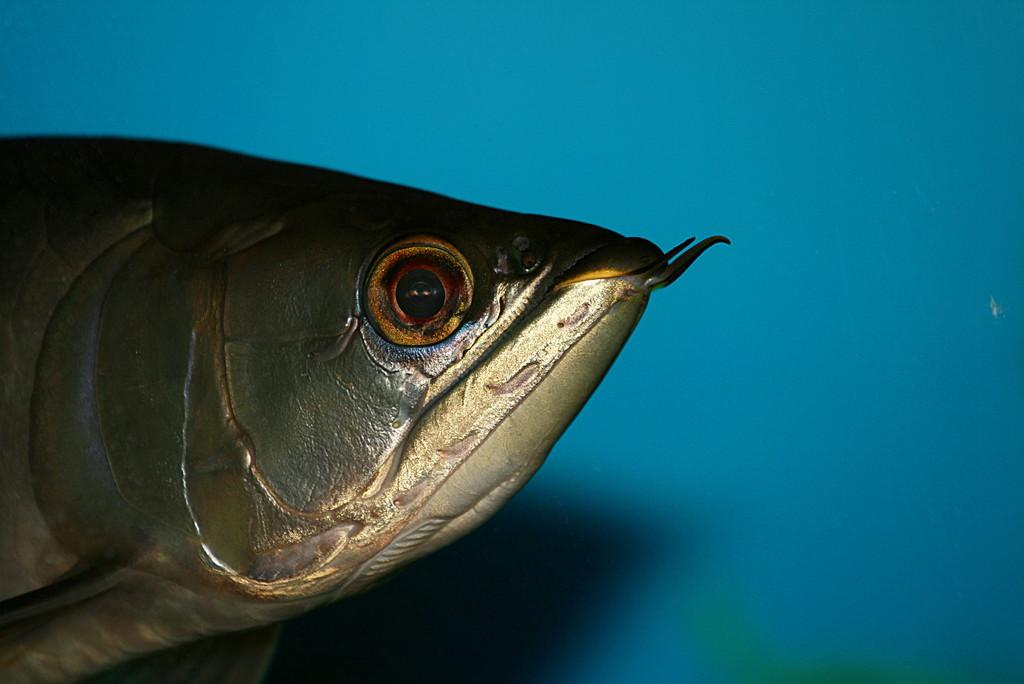What is the main subject of the picture? The main subject of the picture is a fish. Can you describe the surroundings of the fish? There is a wall beside the fish. What type of duck is the owner holding in their pocket in the image? There is no duck or owner present in the image, and therefore no such activity can be observed. 